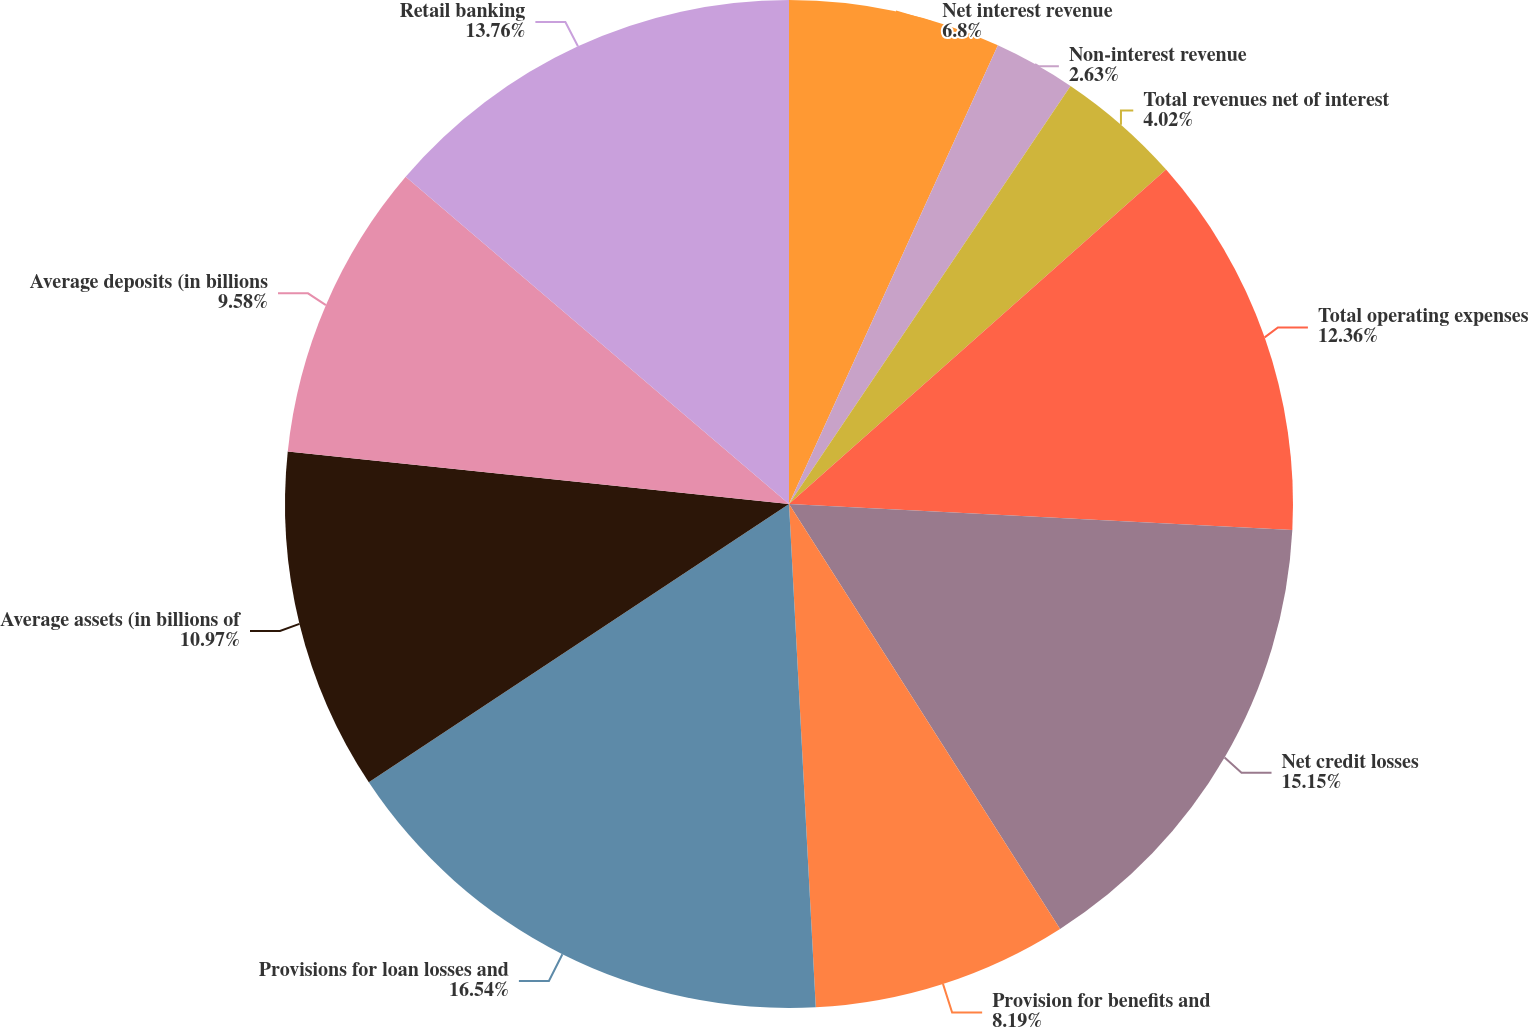Convert chart. <chart><loc_0><loc_0><loc_500><loc_500><pie_chart><fcel>Net interest revenue<fcel>Non-interest revenue<fcel>Total revenues net of interest<fcel>Total operating expenses<fcel>Net credit losses<fcel>Provision for benefits and<fcel>Provisions for loan losses and<fcel>Average assets (in billions of<fcel>Average deposits (in billions<fcel>Retail banking<nl><fcel>6.8%<fcel>2.63%<fcel>4.02%<fcel>12.36%<fcel>15.14%<fcel>8.19%<fcel>16.53%<fcel>10.97%<fcel>9.58%<fcel>13.75%<nl></chart> 